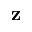<formula> <loc_0><loc_0><loc_500><loc_500>z</formula> 